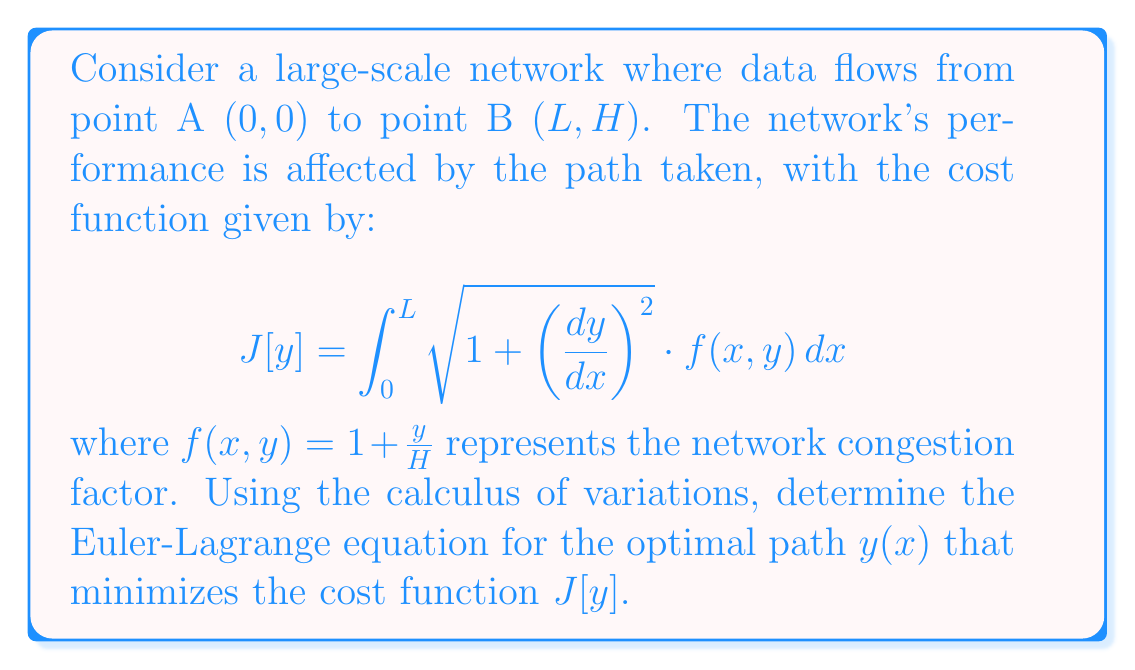Can you answer this question? To solve this problem, we'll use the Euler-Lagrange equation from the calculus of variations. The steps are as follows:

1) The general form of the Euler-Lagrange equation is:

   $$\frac{\partial F}{\partial y} - \frac{d}{dx}\left(\frac{\partial F}{\partial y'}\right) = 0$$

   where $F(x,y,y') = \sqrt{1 + (y')^2} \cdot f(x,y)$ and $y' = \frac{dy}{dx}$.

2) Calculate $\frac{\partial F}{\partial y}$:
   
   $$\frac{\partial F}{\partial y} = \sqrt{1 + (y')^2} \cdot \frac{\partial f}{\partial y} = \sqrt{1 + (y')^2} \cdot \frac{1}{H}$$

3) Calculate $\frac{\partial F}{\partial y'}$:
   
   $$\frac{\partial F}{\partial y'} = \frac{y'}{\sqrt{1 + (y')^2}} \cdot f(x,y) = \frac{y'}{\sqrt{1 + (y')^2}} \cdot (1 + \frac{y}{H})$$

4) Calculate $\frac{d}{dx}\left(\frac{\partial F}{\partial y'}\right)$:
   
   $$\frac{d}{dx}\left(\frac{\partial F}{\partial y'}\right) = \frac{d}{dx}\left[\frac{y'}{\sqrt{1 + (y')^2}} \cdot (1 + \frac{y}{H})\right]$$
   
   Using the product rule and chain rule, this expands to:
   
   $$\frac{y''}{\sqrt{1 + (y')^2}} \cdot (1 + \frac{y}{H}) - \frac{(y')^2 y''}{(1 + (y')^2)^{3/2}} \cdot (1 + \frac{y}{H}) + \frac{y'}{\sqrt{1 + (y')^2}} \cdot \frac{y'}{H}$$

5) Substitute these terms into the Euler-Lagrange equation:

   $$\sqrt{1 + (y')^2} \cdot \frac{1}{H} - \left[\frac{y''}{\sqrt{1 + (y')^2}} \cdot (1 + \frac{y}{H}) - \frac{(y')^2 y''}{(1 + (y')^2)^{3/2}} \cdot (1 + \frac{y}{H}) + \frac{y'}{\sqrt{1 + (y')^2}} \cdot \frac{y'}{H}\right] = 0$$

This is the Euler-Lagrange equation for the optimal path $y(x)$ that minimizes the cost function $J[y]$.
Answer: $$\sqrt{1 + (y')^2} \cdot \frac{1}{H} - \left[\frac{y''}{\sqrt{1 + (y')^2}} \cdot (1 + \frac{y}{H}) - \frac{(y')^2 y''}{(1 + (y')^2)^{3/2}} \cdot (1 + \frac{y}{H}) + \frac{y'}{\sqrt{1 + (y')^2}} \cdot \frac{y'}{H}\right] = 0$$ 